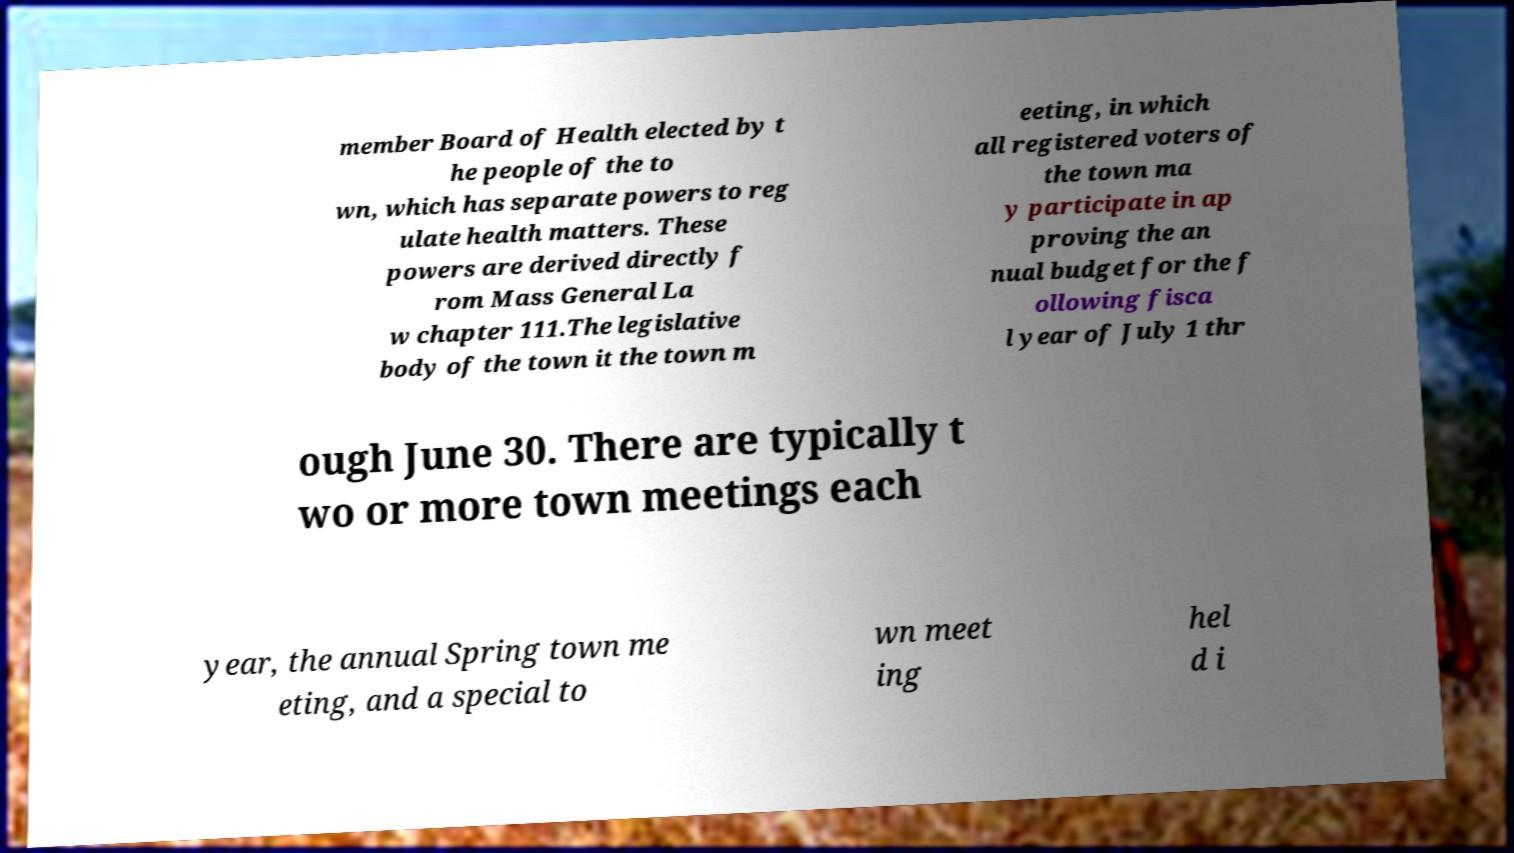There's text embedded in this image that I need extracted. Can you transcribe it verbatim? member Board of Health elected by t he people of the to wn, which has separate powers to reg ulate health matters. These powers are derived directly f rom Mass General La w chapter 111.The legislative body of the town it the town m eeting, in which all registered voters of the town ma y participate in ap proving the an nual budget for the f ollowing fisca l year of July 1 thr ough June 30. There are typically t wo or more town meetings each year, the annual Spring town me eting, and a special to wn meet ing hel d i 